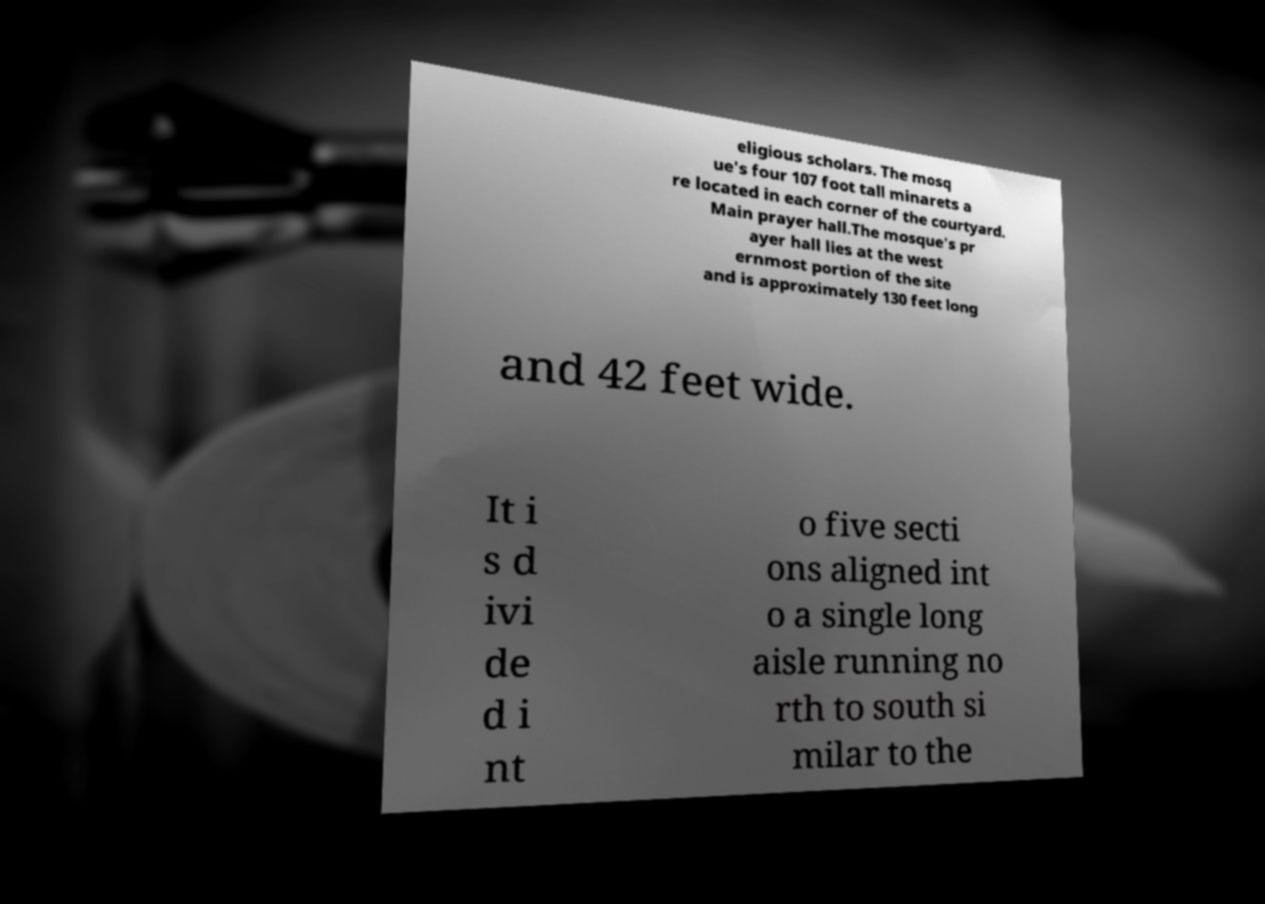Please read and relay the text visible in this image. What does it say? eligious scholars. The mosq ue's four 107 foot tall minarets a re located in each corner of the courtyard. Main prayer hall.The mosque's pr ayer hall lies at the west ernmost portion of the site and is approximately 130 feet long and 42 feet wide. It i s d ivi de d i nt o five secti ons aligned int o a single long aisle running no rth to south si milar to the 